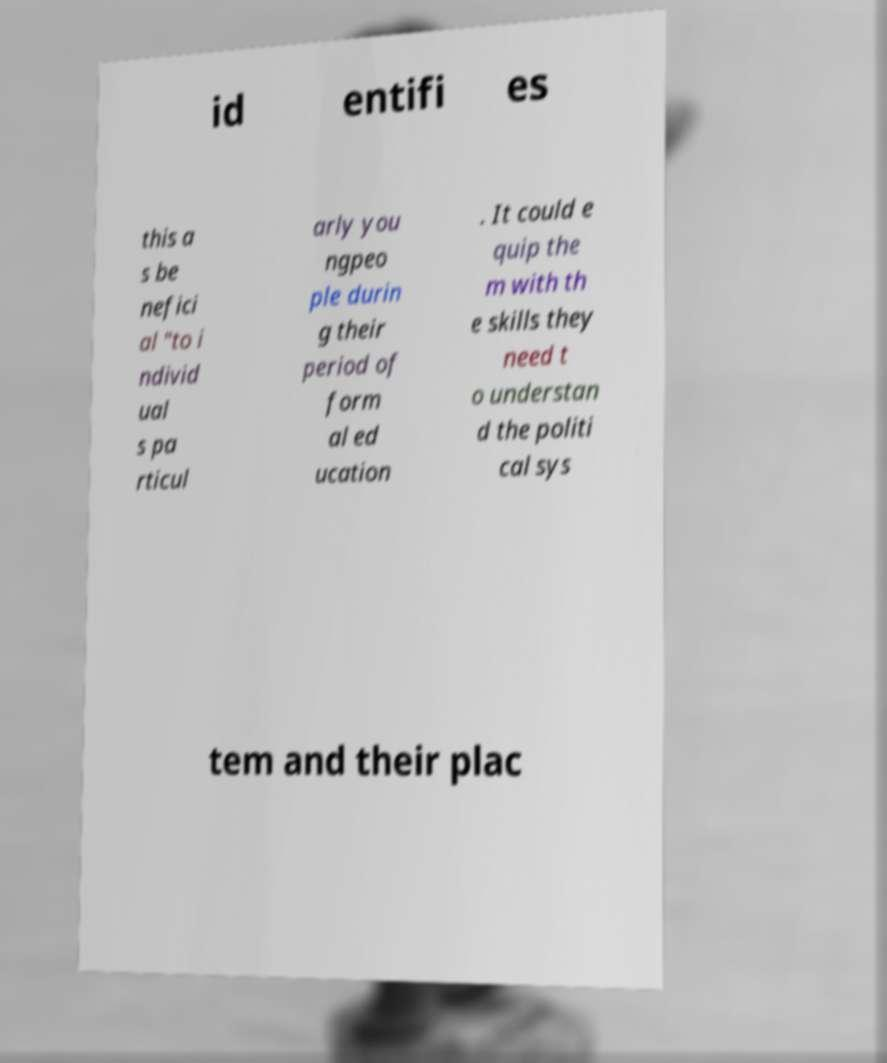Please identify and transcribe the text found in this image. id entifi es this a s be nefici al "to i ndivid ual s pa rticul arly you ngpeo ple durin g their period of form al ed ucation . It could e quip the m with th e skills they need t o understan d the politi cal sys tem and their plac 